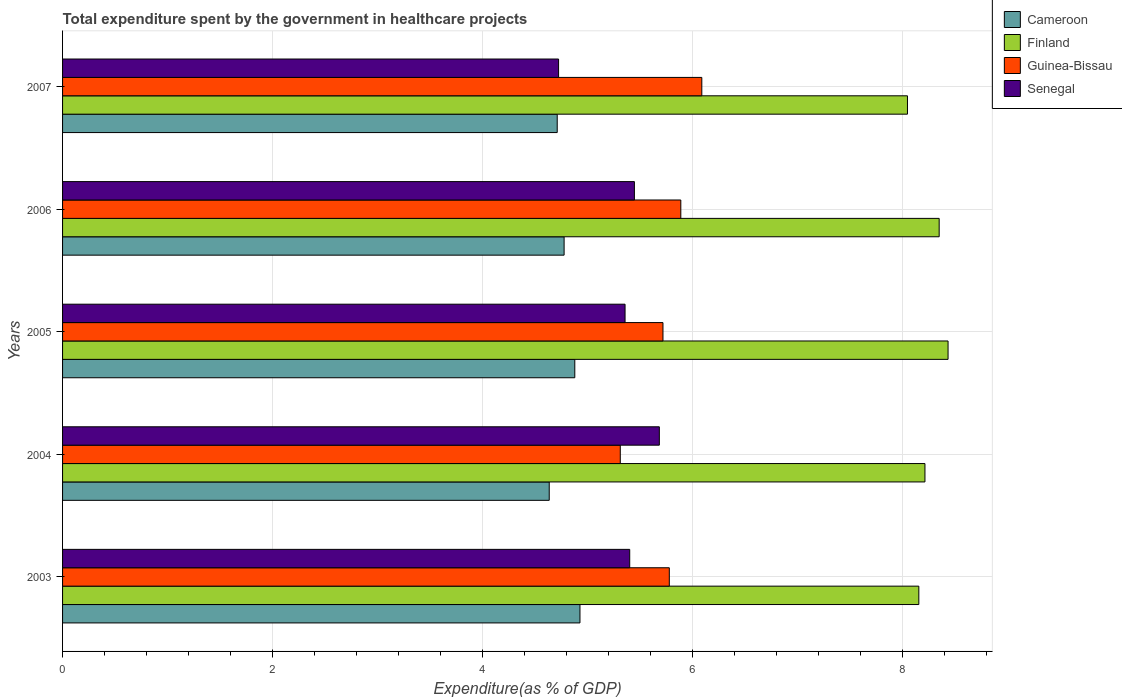How many different coloured bars are there?
Your answer should be compact. 4. Are the number of bars per tick equal to the number of legend labels?
Your response must be concise. Yes. Are the number of bars on each tick of the Y-axis equal?
Your answer should be very brief. Yes. In how many cases, is the number of bars for a given year not equal to the number of legend labels?
Give a very brief answer. 0. What is the total expenditure spent by the government in healthcare projects in Senegal in 2003?
Keep it short and to the point. 5.4. Across all years, what is the maximum total expenditure spent by the government in healthcare projects in Cameroon?
Your answer should be compact. 4.93. Across all years, what is the minimum total expenditure spent by the government in healthcare projects in Senegal?
Offer a terse response. 4.72. In which year was the total expenditure spent by the government in healthcare projects in Guinea-Bissau maximum?
Offer a very short reply. 2007. What is the total total expenditure spent by the government in healthcare projects in Finland in the graph?
Your answer should be compact. 41.18. What is the difference between the total expenditure spent by the government in healthcare projects in Senegal in 2003 and that in 2004?
Provide a short and direct response. -0.28. What is the difference between the total expenditure spent by the government in healthcare projects in Senegal in 2006 and the total expenditure spent by the government in healthcare projects in Finland in 2007?
Your response must be concise. -2.6. What is the average total expenditure spent by the government in healthcare projects in Senegal per year?
Provide a short and direct response. 5.32. In the year 2007, what is the difference between the total expenditure spent by the government in healthcare projects in Guinea-Bissau and total expenditure spent by the government in healthcare projects in Cameroon?
Make the answer very short. 1.38. What is the ratio of the total expenditure spent by the government in healthcare projects in Guinea-Bissau in 2003 to that in 2004?
Keep it short and to the point. 1.09. Is the difference between the total expenditure spent by the government in healthcare projects in Guinea-Bissau in 2004 and 2005 greater than the difference between the total expenditure spent by the government in healthcare projects in Cameroon in 2004 and 2005?
Offer a very short reply. No. What is the difference between the highest and the second highest total expenditure spent by the government in healthcare projects in Cameroon?
Provide a short and direct response. 0.05. What is the difference between the highest and the lowest total expenditure spent by the government in healthcare projects in Senegal?
Your answer should be compact. 0.96. In how many years, is the total expenditure spent by the government in healthcare projects in Finland greater than the average total expenditure spent by the government in healthcare projects in Finland taken over all years?
Offer a terse response. 2. Is the sum of the total expenditure spent by the government in healthcare projects in Cameroon in 2004 and 2007 greater than the maximum total expenditure spent by the government in healthcare projects in Finland across all years?
Provide a succinct answer. Yes. What does the 1st bar from the top in 2007 represents?
Make the answer very short. Senegal. What does the 3rd bar from the bottom in 2003 represents?
Offer a very short reply. Guinea-Bissau. Is it the case that in every year, the sum of the total expenditure spent by the government in healthcare projects in Cameroon and total expenditure spent by the government in healthcare projects in Finland is greater than the total expenditure spent by the government in healthcare projects in Senegal?
Offer a terse response. Yes. How many bars are there?
Offer a very short reply. 20. How many years are there in the graph?
Your answer should be compact. 5. What is the difference between two consecutive major ticks on the X-axis?
Ensure brevity in your answer.  2. What is the title of the graph?
Make the answer very short. Total expenditure spent by the government in healthcare projects. What is the label or title of the X-axis?
Make the answer very short. Expenditure(as % of GDP). What is the Expenditure(as % of GDP) of Cameroon in 2003?
Your answer should be very brief. 4.93. What is the Expenditure(as % of GDP) of Finland in 2003?
Keep it short and to the point. 8.15. What is the Expenditure(as % of GDP) in Guinea-Bissau in 2003?
Your answer should be compact. 5.78. What is the Expenditure(as % of GDP) in Senegal in 2003?
Keep it short and to the point. 5.4. What is the Expenditure(as % of GDP) in Cameroon in 2004?
Offer a terse response. 4.63. What is the Expenditure(as % of GDP) in Finland in 2004?
Keep it short and to the point. 8.21. What is the Expenditure(as % of GDP) in Guinea-Bissau in 2004?
Provide a succinct answer. 5.31. What is the Expenditure(as % of GDP) of Senegal in 2004?
Provide a short and direct response. 5.68. What is the Expenditure(as % of GDP) of Cameroon in 2005?
Offer a very short reply. 4.88. What is the Expenditure(as % of GDP) of Finland in 2005?
Provide a succinct answer. 8.43. What is the Expenditure(as % of GDP) of Guinea-Bissau in 2005?
Give a very brief answer. 5.72. What is the Expenditure(as % of GDP) in Senegal in 2005?
Your answer should be compact. 5.35. What is the Expenditure(as % of GDP) in Cameroon in 2006?
Offer a very short reply. 4.77. What is the Expenditure(as % of GDP) of Finland in 2006?
Offer a very short reply. 8.34. What is the Expenditure(as % of GDP) in Guinea-Bissau in 2006?
Give a very brief answer. 5.89. What is the Expenditure(as % of GDP) in Senegal in 2006?
Make the answer very short. 5.44. What is the Expenditure(as % of GDP) of Cameroon in 2007?
Give a very brief answer. 4.71. What is the Expenditure(as % of GDP) in Finland in 2007?
Keep it short and to the point. 8.04. What is the Expenditure(as % of GDP) in Guinea-Bissau in 2007?
Ensure brevity in your answer.  6.09. What is the Expenditure(as % of GDP) of Senegal in 2007?
Give a very brief answer. 4.72. Across all years, what is the maximum Expenditure(as % of GDP) of Cameroon?
Provide a short and direct response. 4.93. Across all years, what is the maximum Expenditure(as % of GDP) of Finland?
Make the answer very short. 8.43. Across all years, what is the maximum Expenditure(as % of GDP) in Guinea-Bissau?
Offer a terse response. 6.09. Across all years, what is the maximum Expenditure(as % of GDP) in Senegal?
Provide a short and direct response. 5.68. Across all years, what is the minimum Expenditure(as % of GDP) of Cameroon?
Your answer should be compact. 4.63. Across all years, what is the minimum Expenditure(as % of GDP) of Finland?
Your answer should be very brief. 8.04. Across all years, what is the minimum Expenditure(as % of GDP) in Guinea-Bissau?
Provide a short and direct response. 5.31. Across all years, what is the minimum Expenditure(as % of GDP) in Senegal?
Offer a very short reply. 4.72. What is the total Expenditure(as % of GDP) in Cameroon in the graph?
Offer a terse response. 23.92. What is the total Expenditure(as % of GDP) in Finland in the graph?
Keep it short and to the point. 41.18. What is the total Expenditure(as % of GDP) in Guinea-Bissau in the graph?
Provide a succinct answer. 28.77. What is the total Expenditure(as % of GDP) of Senegal in the graph?
Give a very brief answer. 26.6. What is the difference between the Expenditure(as % of GDP) of Cameroon in 2003 and that in 2004?
Make the answer very short. 0.29. What is the difference between the Expenditure(as % of GDP) of Finland in 2003 and that in 2004?
Offer a terse response. -0.06. What is the difference between the Expenditure(as % of GDP) of Guinea-Bissau in 2003 and that in 2004?
Provide a succinct answer. 0.47. What is the difference between the Expenditure(as % of GDP) in Senegal in 2003 and that in 2004?
Offer a terse response. -0.28. What is the difference between the Expenditure(as % of GDP) in Cameroon in 2003 and that in 2005?
Keep it short and to the point. 0.05. What is the difference between the Expenditure(as % of GDP) of Finland in 2003 and that in 2005?
Make the answer very short. -0.28. What is the difference between the Expenditure(as % of GDP) in Guinea-Bissau in 2003 and that in 2005?
Offer a terse response. 0.06. What is the difference between the Expenditure(as % of GDP) in Senegal in 2003 and that in 2005?
Your answer should be compact. 0.04. What is the difference between the Expenditure(as % of GDP) of Cameroon in 2003 and that in 2006?
Ensure brevity in your answer.  0.15. What is the difference between the Expenditure(as % of GDP) in Finland in 2003 and that in 2006?
Provide a short and direct response. -0.19. What is the difference between the Expenditure(as % of GDP) in Guinea-Bissau in 2003 and that in 2006?
Make the answer very short. -0.11. What is the difference between the Expenditure(as % of GDP) in Senegal in 2003 and that in 2006?
Make the answer very short. -0.04. What is the difference between the Expenditure(as % of GDP) in Cameroon in 2003 and that in 2007?
Offer a very short reply. 0.22. What is the difference between the Expenditure(as % of GDP) of Finland in 2003 and that in 2007?
Make the answer very short. 0.11. What is the difference between the Expenditure(as % of GDP) in Guinea-Bissau in 2003 and that in 2007?
Keep it short and to the point. -0.31. What is the difference between the Expenditure(as % of GDP) in Senegal in 2003 and that in 2007?
Provide a short and direct response. 0.68. What is the difference between the Expenditure(as % of GDP) in Cameroon in 2004 and that in 2005?
Keep it short and to the point. -0.24. What is the difference between the Expenditure(as % of GDP) of Finland in 2004 and that in 2005?
Your answer should be compact. -0.22. What is the difference between the Expenditure(as % of GDP) in Guinea-Bissau in 2004 and that in 2005?
Keep it short and to the point. -0.41. What is the difference between the Expenditure(as % of GDP) in Senegal in 2004 and that in 2005?
Offer a very short reply. 0.33. What is the difference between the Expenditure(as % of GDP) in Cameroon in 2004 and that in 2006?
Ensure brevity in your answer.  -0.14. What is the difference between the Expenditure(as % of GDP) in Finland in 2004 and that in 2006?
Give a very brief answer. -0.14. What is the difference between the Expenditure(as % of GDP) of Guinea-Bissau in 2004 and that in 2006?
Give a very brief answer. -0.58. What is the difference between the Expenditure(as % of GDP) in Senegal in 2004 and that in 2006?
Keep it short and to the point. 0.24. What is the difference between the Expenditure(as % of GDP) in Cameroon in 2004 and that in 2007?
Make the answer very short. -0.08. What is the difference between the Expenditure(as % of GDP) of Finland in 2004 and that in 2007?
Keep it short and to the point. 0.17. What is the difference between the Expenditure(as % of GDP) in Guinea-Bissau in 2004 and that in 2007?
Give a very brief answer. -0.78. What is the difference between the Expenditure(as % of GDP) of Senegal in 2004 and that in 2007?
Your response must be concise. 0.96. What is the difference between the Expenditure(as % of GDP) in Cameroon in 2005 and that in 2006?
Provide a succinct answer. 0.1. What is the difference between the Expenditure(as % of GDP) of Finland in 2005 and that in 2006?
Provide a short and direct response. 0.08. What is the difference between the Expenditure(as % of GDP) in Guinea-Bissau in 2005 and that in 2006?
Make the answer very short. -0.17. What is the difference between the Expenditure(as % of GDP) of Senegal in 2005 and that in 2006?
Provide a short and direct response. -0.09. What is the difference between the Expenditure(as % of GDP) of Cameroon in 2005 and that in 2007?
Give a very brief answer. 0.17. What is the difference between the Expenditure(as % of GDP) in Finland in 2005 and that in 2007?
Keep it short and to the point. 0.39. What is the difference between the Expenditure(as % of GDP) of Guinea-Bissau in 2005 and that in 2007?
Offer a very short reply. -0.37. What is the difference between the Expenditure(as % of GDP) of Senegal in 2005 and that in 2007?
Provide a short and direct response. 0.63. What is the difference between the Expenditure(as % of GDP) of Cameroon in 2006 and that in 2007?
Make the answer very short. 0.07. What is the difference between the Expenditure(as % of GDP) in Finland in 2006 and that in 2007?
Keep it short and to the point. 0.3. What is the difference between the Expenditure(as % of GDP) of Senegal in 2006 and that in 2007?
Provide a succinct answer. 0.72. What is the difference between the Expenditure(as % of GDP) in Cameroon in 2003 and the Expenditure(as % of GDP) in Finland in 2004?
Provide a short and direct response. -3.28. What is the difference between the Expenditure(as % of GDP) of Cameroon in 2003 and the Expenditure(as % of GDP) of Guinea-Bissau in 2004?
Ensure brevity in your answer.  -0.38. What is the difference between the Expenditure(as % of GDP) of Cameroon in 2003 and the Expenditure(as % of GDP) of Senegal in 2004?
Offer a very short reply. -0.76. What is the difference between the Expenditure(as % of GDP) of Finland in 2003 and the Expenditure(as % of GDP) of Guinea-Bissau in 2004?
Give a very brief answer. 2.84. What is the difference between the Expenditure(as % of GDP) of Finland in 2003 and the Expenditure(as % of GDP) of Senegal in 2004?
Provide a short and direct response. 2.47. What is the difference between the Expenditure(as % of GDP) of Guinea-Bissau in 2003 and the Expenditure(as % of GDP) of Senegal in 2004?
Keep it short and to the point. 0.09. What is the difference between the Expenditure(as % of GDP) of Cameroon in 2003 and the Expenditure(as % of GDP) of Finland in 2005?
Offer a terse response. -3.5. What is the difference between the Expenditure(as % of GDP) in Cameroon in 2003 and the Expenditure(as % of GDP) in Guinea-Bissau in 2005?
Provide a succinct answer. -0.79. What is the difference between the Expenditure(as % of GDP) in Cameroon in 2003 and the Expenditure(as % of GDP) in Senegal in 2005?
Your answer should be compact. -0.43. What is the difference between the Expenditure(as % of GDP) in Finland in 2003 and the Expenditure(as % of GDP) in Guinea-Bissau in 2005?
Offer a very short reply. 2.44. What is the difference between the Expenditure(as % of GDP) of Finland in 2003 and the Expenditure(as % of GDP) of Senegal in 2005?
Your answer should be very brief. 2.8. What is the difference between the Expenditure(as % of GDP) of Guinea-Bissau in 2003 and the Expenditure(as % of GDP) of Senegal in 2005?
Provide a succinct answer. 0.42. What is the difference between the Expenditure(as % of GDP) of Cameroon in 2003 and the Expenditure(as % of GDP) of Finland in 2006?
Keep it short and to the point. -3.42. What is the difference between the Expenditure(as % of GDP) in Cameroon in 2003 and the Expenditure(as % of GDP) in Guinea-Bissau in 2006?
Offer a terse response. -0.96. What is the difference between the Expenditure(as % of GDP) in Cameroon in 2003 and the Expenditure(as % of GDP) in Senegal in 2006?
Make the answer very short. -0.52. What is the difference between the Expenditure(as % of GDP) of Finland in 2003 and the Expenditure(as % of GDP) of Guinea-Bissau in 2006?
Your response must be concise. 2.27. What is the difference between the Expenditure(as % of GDP) of Finland in 2003 and the Expenditure(as % of GDP) of Senegal in 2006?
Provide a short and direct response. 2.71. What is the difference between the Expenditure(as % of GDP) of Guinea-Bissau in 2003 and the Expenditure(as % of GDP) of Senegal in 2006?
Your response must be concise. 0.33. What is the difference between the Expenditure(as % of GDP) in Cameroon in 2003 and the Expenditure(as % of GDP) in Finland in 2007?
Keep it short and to the point. -3.12. What is the difference between the Expenditure(as % of GDP) in Cameroon in 2003 and the Expenditure(as % of GDP) in Guinea-Bissau in 2007?
Your answer should be very brief. -1.16. What is the difference between the Expenditure(as % of GDP) of Cameroon in 2003 and the Expenditure(as % of GDP) of Senegal in 2007?
Ensure brevity in your answer.  0.2. What is the difference between the Expenditure(as % of GDP) of Finland in 2003 and the Expenditure(as % of GDP) of Guinea-Bissau in 2007?
Ensure brevity in your answer.  2.07. What is the difference between the Expenditure(as % of GDP) of Finland in 2003 and the Expenditure(as % of GDP) of Senegal in 2007?
Make the answer very short. 3.43. What is the difference between the Expenditure(as % of GDP) in Guinea-Bissau in 2003 and the Expenditure(as % of GDP) in Senegal in 2007?
Ensure brevity in your answer.  1.05. What is the difference between the Expenditure(as % of GDP) of Cameroon in 2004 and the Expenditure(as % of GDP) of Finland in 2005?
Your answer should be very brief. -3.8. What is the difference between the Expenditure(as % of GDP) in Cameroon in 2004 and the Expenditure(as % of GDP) in Guinea-Bissau in 2005?
Your answer should be very brief. -1.08. What is the difference between the Expenditure(as % of GDP) in Cameroon in 2004 and the Expenditure(as % of GDP) in Senegal in 2005?
Give a very brief answer. -0.72. What is the difference between the Expenditure(as % of GDP) of Finland in 2004 and the Expenditure(as % of GDP) of Guinea-Bissau in 2005?
Provide a short and direct response. 2.49. What is the difference between the Expenditure(as % of GDP) of Finland in 2004 and the Expenditure(as % of GDP) of Senegal in 2005?
Your answer should be compact. 2.85. What is the difference between the Expenditure(as % of GDP) in Guinea-Bissau in 2004 and the Expenditure(as % of GDP) in Senegal in 2005?
Make the answer very short. -0.05. What is the difference between the Expenditure(as % of GDP) of Cameroon in 2004 and the Expenditure(as % of GDP) of Finland in 2006?
Provide a succinct answer. -3.71. What is the difference between the Expenditure(as % of GDP) of Cameroon in 2004 and the Expenditure(as % of GDP) of Guinea-Bissau in 2006?
Your response must be concise. -1.25. What is the difference between the Expenditure(as % of GDP) in Cameroon in 2004 and the Expenditure(as % of GDP) in Senegal in 2006?
Your answer should be very brief. -0.81. What is the difference between the Expenditure(as % of GDP) in Finland in 2004 and the Expenditure(as % of GDP) in Guinea-Bissau in 2006?
Your answer should be very brief. 2.32. What is the difference between the Expenditure(as % of GDP) in Finland in 2004 and the Expenditure(as % of GDP) in Senegal in 2006?
Your answer should be very brief. 2.77. What is the difference between the Expenditure(as % of GDP) in Guinea-Bissau in 2004 and the Expenditure(as % of GDP) in Senegal in 2006?
Provide a short and direct response. -0.13. What is the difference between the Expenditure(as % of GDP) in Cameroon in 2004 and the Expenditure(as % of GDP) in Finland in 2007?
Offer a terse response. -3.41. What is the difference between the Expenditure(as % of GDP) in Cameroon in 2004 and the Expenditure(as % of GDP) in Guinea-Bissau in 2007?
Offer a terse response. -1.45. What is the difference between the Expenditure(as % of GDP) of Cameroon in 2004 and the Expenditure(as % of GDP) of Senegal in 2007?
Provide a short and direct response. -0.09. What is the difference between the Expenditure(as % of GDP) of Finland in 2004 and the Expenditure(as % of GDP) of Guinea-Bissau in 2007?
Keep it short and to the point. 2.12. What is the difference between the Expenditure(as % of GDP) of Finland in 2004 and the Expenditure(as % of GDP) of Senegal in 2007?
Keep it short and to the point. 3.49. What is the difference between the Expenditure(as % of GDP) of Guinea-Bissau in 2004 and the Expenditure(as % of GDP) of Senegal in 2007?
Your response must be concise. 0.59. What is the difference between the Expenditure(as % of GDP) of Cameroon in 2005 and the Expenditure(as % of GDP) of Finland in 2006?
Offer a very short reply. -3.47. What is the difference between the Expenditure(as % of GDP) in Cameroon in 2005 and the Expenditure(as % of GDP) in Guinea-Bissau in 2006?
Keep it short and to the point. -1.01. What is the difference between the Expenditure(as % of GDP) of Cameroon in 2005 and the Expenditure(as % of GDP) of Senegal in 2006?
Make the answer very short. -0.57. What is the difference between the Expenditure(as % of GDP) of Finland in 2005 and the Expenditure(as % of GDP) of Guinea-Bissau in 2006?
Offer a very short reply. 2.54. What is the difference between the Expenditure(as % of GDP) in Finland in 2005 and the Expenditure(as % of GDP) in Senegal in 2006?
Provide a short and direct response. 2.99. What is the difference between the Expenditure(as % of GDP) in Guinea-Bissau in 2005 and the Expenditure(as % of GDP) in Senegal in 2006?
Your answer should be very brief. 0.27. What is the difference between the Expenditure(as % of GDP) of Cameroon in 2005 and the Expenditure(as % of GDP) of Finland in 2007?
Provide a succinct answer. -3.17. What is the difference between the Expenditure(as % of GDP) in Cameroon in 2005 and the Expenditure(as % of GDP) in Guinea-Bissau in 2007?
Ensure brevity in your answer.  -1.21. What is the difference between the Expenditure(as % of GDP) in Cameroon in 2005 and the Expenditure(as % of GDP) in Senegal in 2007?
Offer a terse response. 0.15. What is the difference between the Expenditure(as % of GDP) in Finland in 2005 and the Expenditure(as % of GDP) in Guinea-Bissau in 2007?
Offer a terse response. 2.34. What is the difference between the Expenditure(as % of GDP) of Finland in 2005 and the Expenditure(as % of GDP) of Senegal in 2007?
Give a very brief answer. 3.71. What is the difference between the Expenditure(as % of GDP) of Guinea-Bissau in 2005 and the Expenditure(as % of GDP) of Senegal in 2007?
Provide a succinct answer. 0.99. What is the difference between the Expenditure(as % of GDP) in Cameroon in 2006 and the Expenditure(as % of GDP) in Finland in 2007?
Provide a short and direct response. -3.27. What is the difference between the Expenditure(as % of GDP) of Cameroon in 2006 and the Expenditure(as % of GDP) of Guinea-Bissau in 2007?
Provide a short and direct response. -1.31. What is the difference between the Expenditure(as % of GDP) in Cameroon in 2006 and the Expenditure(as % of GDP) in Senegal in 2007?
Keep it short and to the point. 0.05. What is the difference between the Expenditure(as % of GDP) of Finland in 2006 and the Expenditure(as % of GDP) of Guinea-Bissau in 2007?
Offer a very short reply. 2.26. What is the difference between the Expenditure(as % of GDP) in Finland in 2006 and the Expenditure(as % of GDP) in Senegal in 2007?
Offer a very short reply. 3.62. What is the difference between the Expenditure(as % of GDP) of Guinea-Bissau in 2006 and the Expenditure(as % of GDP) of Senegal in 2007?
Make the answer very short. 1.16. What is the average Expenditure(as % of GDP) of Cameroon per year?
Make the answer very short. 4.78. What is the average Expenditure(as % of GDP) of Finland per year?
Keep it short and to the point. 8.24. What is the average Expenditure(as % of GDP) of Guinea-Bissau per year?
Provide a succinct answer. 5.75. What is the average Expenditure(as % of GDP) in Senegal per year?
Keep it short and to the point. 5.32. In the year 2003, what is the difference between the Expenditure(as % of GDP) of Cameroon and Expenditure(as % of GDP) of Finland?
Make the answer very short. -3.23. In the year 2003, what is the difference between the Expenditure(as % of GDP) of Cameroon and Expenditure(as % of GDP) of Guinea-Bissau?
Ensure brevity in your answer.  -0.85. In the year 2003, what is the difference between the Expenditure(as % of GDP) in Cameroon and Expenditure(as % of GDP) in Senegal?
Provide a short and direct response. -0.47. In the year 2003, what is the difference between the Expenditure(as % of GDP) of Finland and Expenditure(as % of GDP) of Guinea-Bissau?
Your response must be concise. 2.38. In the year 2003, what is the difference between the Expenditure(as % of GDP) in Finland and Expenditure(as % of GDP) in Senegal?
Provide a short and direct response. 2.75. In the year 2003, what is the difference between the Expenditure(as % of GDP) in Guinea-Bissau and Expenditure(as % of GDP) in Senegal?
Your answer should be very brief. 0.38. In the year 2004, what is the difference between the Expenditure(as % of GDP) in Cameroon and Expenditure(as % of GDP) in Finland?
Offer a terse response. -3.58. In the year 2004, what is the difference between the Expenditure(as % of GDP) of Cameroon and Expenditure(as % of GDP) of Guinea-Bissau?
Make the answer very short. -0.68. In the year 2004, what is the difference between the Expenditure(as % of GDP) of Cameroon and Expenditure(as % of GDP) of Senegal?
Your response must be concise. -1.05. In the year 2004, what is the difference between the Expenditure(as % of GDP) in Finland and Expenditure(as % of GDP) in Guinea-Bissau?
Provide a succinct answer. 2.9. In the year 2004, what is the difference between the Expenditure(as % of GDP) of Finland and Expenditure(as % of GDP) of Senegal?
Provide a short and direct response. 2.53. In the year 2004, what is the difference between the Expenditure(as % of GDP) in Guinea-Bissau and Expenditure(as % of GDP) in Senegal?
Your answer should be very brief. -0.37. In the year 2005, what is the difference between the Expenditure(as % of GDP) in Cameroon and Expenditure(as % of GDP) in Finland?
Offer a very short reply. -3.55. In the year 2005, what is the difference between the Expenditure(as % of GDP) of Cameroon and Expenditure(as % of GDP) of Guinea-Bissau?
Provide a short and direct response. -0.84. In the year 2005, what is the difference between the Expenditure(as % of GDP) in Cameroon and Expenditure(as % of GDP) in Senegal?
Provide a succinct answer. -0.48. In the year 2005, what is the difference between the Expenditure(as % of GDP) in Finland and Expenditure(as % of GDP) in Guinea-Bissau?
Keep it short and to the point. 2.71. In the year 2005, what is the difference between the Expenditure(as % of GDP) in Finland and Expenditure(as % of GDP) in Senegal?
Ensure brevity in your answer.  3.07. In the year 2005, what is the difference between the Expenditure(as % of GDP) of Guinea-Bissau and Expenditure(as % of GDP) of Senegal?
Offer a terse response. 0.36. In the year 2006, what is the difference between the Expenditure(as % of GDP) in Cameroon and Expenditure(as % of GDP) in Finland?
Your answer should be very brief. -3.57. In the year 2006, what is the difference between the Expenditure(as % of GDP) of Cameroon and Expenditure(as % of GDP) of Guinea-Bissau?
Offer a terse response. -1.11. In the year 2006, what is the difference between the Expenditure(as % of GDP) of Cameroon and Expenditure(as % of GDP) of Senegal?
Provide a short and direct response. -0.67. In the year 2006, what is the difference between the Expenditure(as % of GDP) of Finland and Expenditure(as % of GDP) of Guinea-Bissau?
Offer a very short reply. 2.46. In the year 2006, what is the difference between the Expenditure(as % of GDP) in Finland and Expenditure(as % of GDP) in Senegal?
Make the answer very short. 2.9. In the year 2006, what is the difference between the Expenditure(as % of GDP) in Guinea-Bissau and Expenditure(as % of GDP) in Senegal?
Give a very brief answer. 0.44. In the year 2007, what is the difference between the Expenditure(as % of GDP) in Cameroon and Expenditure(as % of GDP) in Finland?
Make the answer very short. -3.33. In the year 2007, what is the difference between the Expenditure(as % of GDP) in Cameroon and Expenditure(as % of GDP) in Guinea-Bissau?
Provide a short and direct response. -1.38. In the year 2007, what is the difference between the Expenditure(as % of GDP) in Cameroon and Expenditure(as % of GDP) in Senegal?
Ensure brevity in your answer.  -0.01. In the year 2007, what is the difference between the Expenditure(as % of GDP) in Finland and Expenditure(as % of GDP) in Guinea-Bissau?
Offer a very short reply. 1.96. In the year 2007, what is the difference between the Expenditure(as % of GDP) of Finland and Expenditure(as % of GDP) of Senegal?
Ensure brevity in your answer.  3.32. In the year 2007, what is the difference between the Expenditure(as % of GDP) of Guinea-Bissau and Expenditure(as % of GDP) of Senegal?
Your answer should be compact. 1.36. What is the ratio of the Expenditure(as % of GDP) in Cameroon in 2003 to that in 2004?
Provide a short and direct response. 1.06. What is the ratio of the Expenditure(as % of GDP) of Guinea-Bissau in 2003 to that in 2004?
Give a very brief answer. 1.09. What is the ratio of the Expenditure(as % of GDP) of Senegal in 2003 to that in 2004?
Provide a succinct answer. 0.95. What is the ratio of the Expenditure(as % of GDP) of Cameroon in 2003 to that in 2005?
Offer a terse response. 1.01. What is the ratio of the Expenditure(as % of GDP) of Guinea-Bissau in 2003 to that in 2005?
Provide a short and direct response. 1.01. What is the ratio of the Expenditure(as % of GDP) in Senegal in 2003 to that in 2005?
Provide a short and direct response. 1.01. What is the ratio of the Expenditure(as % of GDP) of Cameroon in 2003 to that in 2006?
Provide a succinct answer. 1.03. What is the ratio of the Expenditure(as % of GDP) of Finland in 2003 to that in 2006?
Give a very brief answer. 0.98. What is the ratio of the Expenditure(as % of GDP) of Guinea-Bissau in 2003 to that in 2006?
Provide a succinct answer. 0.98. What is the ratio of the Expenditure(as % of GDP) in Cameroon in 2003 to that in 2007?
Provide a short and direct response. 1.05. What is the ratio of the Expenditure(as % of GDP) in Finland in 2003 to that in 2007?
Ensure brevity in your answer.  1.01. What is the ratio of the Expenditure(as % of GDP) in Guinea-Bissau in 2003 to that in 2007?
Your answer should be very brief. 0.95. What is the ratio of the Expenditure(as % of GDP) of Senegal in 2003 to that in 2007?
Provide a succinct answer. 1.14. What is the ratio of the Expenditure(as % of GDP) in Cameroon in 2004 to that in 2005?
Your response must be concise. 0.95. What is the ratio of the Expenditure(as % of GDP) in Finland in 2004 to that in 2005?
Provide a succinct answer. 0.97. What is the ratio of the Expenditure(as % of GDP) in Guinea-Bissau in 2004 to that in 2005?
Ensure brevity in your answer.  0.93. What is the ratio of the Expenditure(as % of GDP) in Senegal in 2004 to that in 2005?
Make the answer very short. 1.06. What is the ratio of the Expenditure(as % of GDP) of Cameroon in 2004 to that in 2006?
Your answer should be compact. 0.97. What is the ratio of the Expenditure(as % of GDP) in Finland in 2004 to that in 2006?
Your answer should be very brief. 0.98. What is the ratio of the Expenditure(as % of GDP) of Guinea-Bissau in 2004 to that in 2006?
Provide a short and direct response. 0.9. What is the ratio of the Expenditure(as % of GDP) of Senegal in 2004 to that in 2006?
Your answer should be very brief. 1.04. What is the ratio of the Expenditure(as % of GDP) of Cameroon in 2004 to that in 2007?
Provide a short and direct response. 0.98. What is the ratio of the Expenditure(as % of GDP) of Finland in 2004 to that in 2007?
Offer a terse response. 1.02. What is the ratio of the Expenditure(as % of GDP) in Guinea-Bissau in 2004 to that in 2007?
Your answer should be very brief. 0.87. What is the ratio of the Expenditure(as % of GDP) of Senegal in 2004 to that in 2007?
Give a very brief answer. 1.2. What is the ratio of the Expenditure(as % of GDP) in Cameroon in 2005 to that in 2006?
Give a very brief answer. 1.02. What is the ratio of the Expenditure(as % of GDP) of Finland in 2005 to that in 2006?
Your answer should be compact. 1.01. What is the ratio of the Expenditure(as % of GDP) in Guinea-Bissau in 2005 to that in 2006?
Your answer should be compact. 0.97. What is the ratio of the Expenditure(as % of GDP) of Senegal in 2005 to that in 2006?
Offer a terse response. 0.98. What is the ratio of the Expenditure(as % of GDP) of Cameroon in 2005 to that in 2007?
Provide a short and direct response. 1.04. What is the ratio of the Expenditure(as % of GDP) of Finland in 2005 to that in 2007?
Your response must be concise. 1.05. What is the ratio of the Expenditure(as % of GDP) in Guinea-Bissau in 2005 to that in 2007?
Your response must be concise. 0.94. What is the ratio of the Expenditure(as % of GDP) in Senegal in 2005 to that in 2007?
Your answer should be very brief. 1.13. What is the ratio of the Expenditure(as % of GDP) of Cameroon in 2006 to that in 2007?
Give a very brief answer. 1.01. What is the ratio of the Expenditure(as % of GDP) in Finland in 2006 to that in 2007?
Offer a very short reply. 1.04. What is the ratio of the Expenditure(as % of GDP) of Guinea-Bissau in 2006 to that in 2007?
Make the answer very short. 0.97. What is the ratio of the Expenditure(as % of GDP) in Senegal in 2006 to that in 2007?
Provide a succinct answer. 1.15. What is the difference between the highest and the second highest Expenditure(as % of GDP) in Cameroon?
Provide a short and direct response. 0.05. What is the difference between the highest and the second highest Expenditure(as % of GDP) of Finland?
Your response must be concise. 0.08. What is the difference between the highest and the second highest Expenditure(as % of GDP) of Senegal?
Offer a very short reply. 0.24. What is the difference between the highest and the lowest Expenditure(as % of GDP) of Cameroon?
Give a very brief answer. 0.29. What is the difference between the highest and the lowest Expenditure(as % of GDP) of Finland?
Offer a terse response. 0.39. What is the difference between the highest and the lowest Expenditure(as % of GDP) in Guinea-Bissau?
Your answer should be compact. 0.78. What is the difference between the highest and the lowest Expenditure(as % of GDP) in Senegal?
Give a very brief answer. 0.96. 